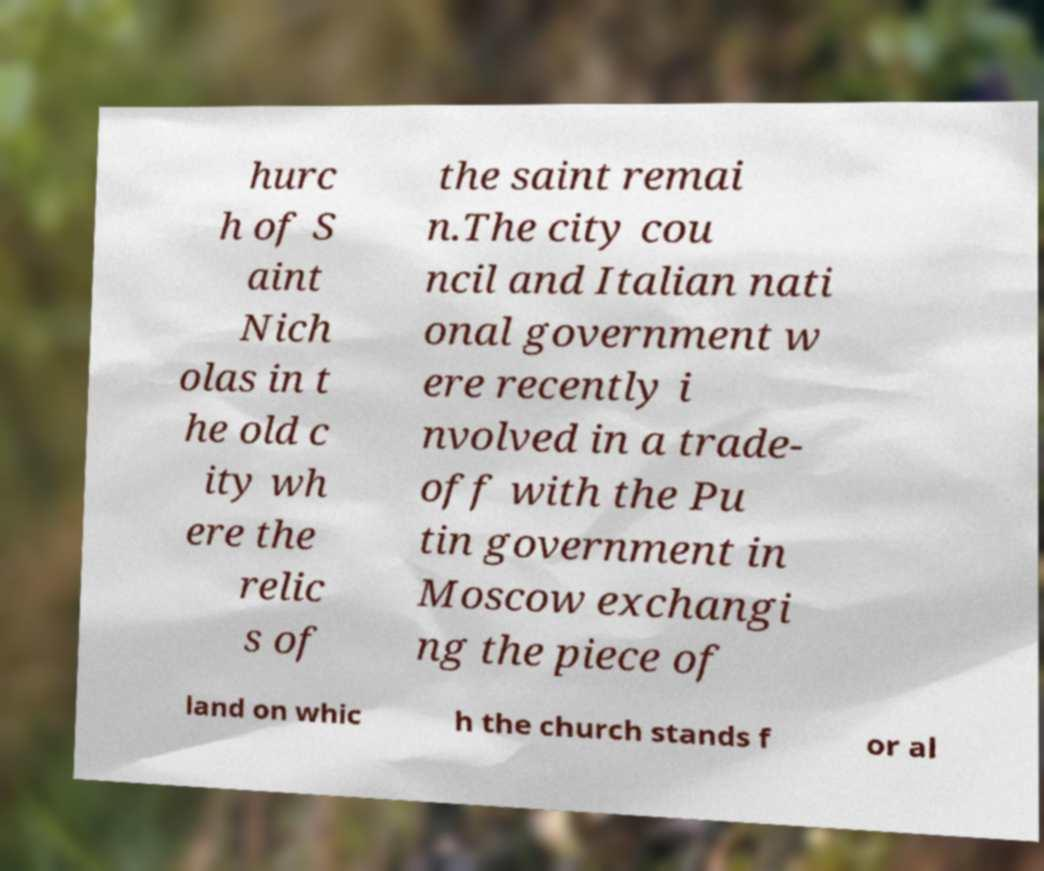What messages or text are displayed in this image? I need them in a readable, typed format. hurc h of S aint Nich olas in t he old c ity wh ere the relic s of the saint remai n.The city cou ncil and Italian nati onal government w ere recently i nvolved in a trade- off with the Pu tin government in Moscow exchangi ng the piece of land on whic h the church stands f or al 